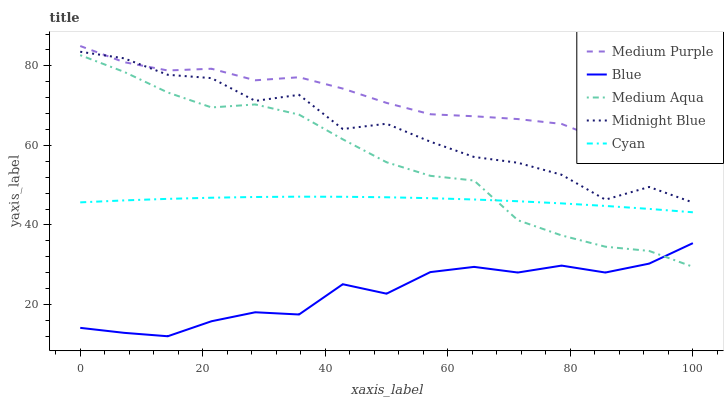Does Blue have the minimum area under the curve?
Answer yes or no. Yes. Does Medium Purple have the maximum area under the curve?
Answer yes or no. Yes. Does Medium Aqua have the minimum area under the curve?
Answer yes or no. No. Does Medium Aqua have the maximum area under the curve?
Answer yes or no. No. Is Cyan the smoothest?
Answer yes or no. Yes. Is Midnight Blue the roughest?
Answer yes or no. Yes. Is Blue the smoothest?
Answer yes or no. No. Is Blue the roughest?
Answer yes or no. No. Does Blue have the lowest value?
Answer yes or no. Yes. Does Medium Aqua have the lowest value?
Answer yes or no. No. Does Medium Purple have the highest value?
Answer yes or no. Yes. Does Medium Aqua have the highest value?
Answer yes or no. No. Is Medium Aqua less than Midnight Blue?
Answer yes or no. Yes. Is Midnight Blue greater than Blue?
Answer yes or no. Yes. Does Medium Purple intersect Midnight Blue?
Answer yes or no. Yes. Is Medium Purple less than Midnight Blue?
Answer yes or no. No. Is Medium Purple greater than Midnight Blue?
Answer yes or no. No. Does Medium Aqua intersect Midnight Blue?
Answer yes or no. No. 